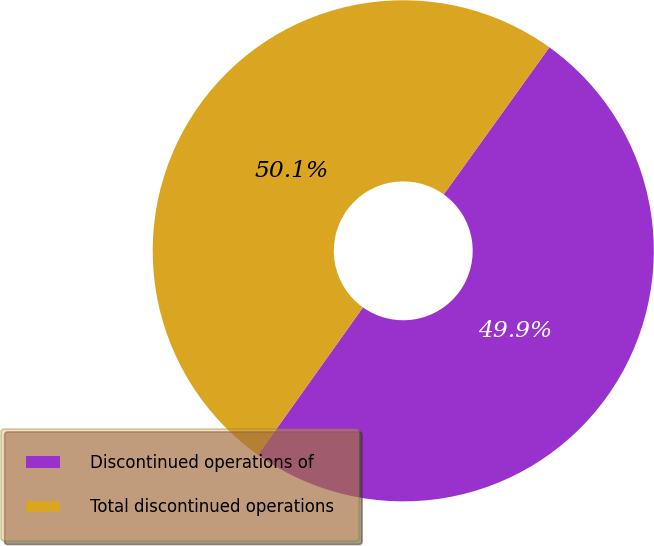Convert chart to OTSL. <chart><loc_0><loc_0><loc_500><loc_500><pie_chart><fcel>Discontinued operations of<fcel>Total discontinued operations<nl><fcel>49.94%<fcel>50.06%<nl></chart> 